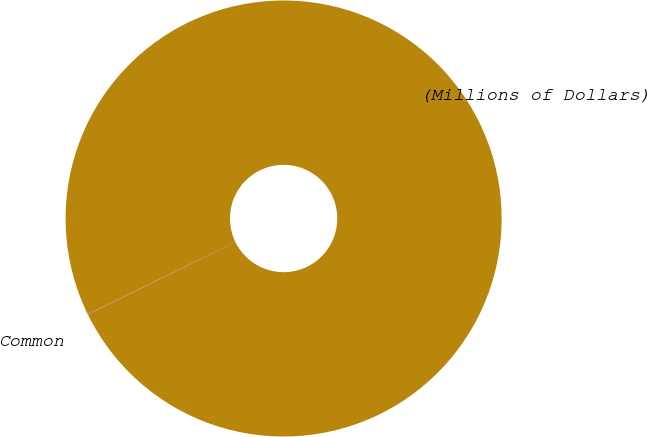Convert chart. <chart><loc_0><loc_0><loc_500><loc_500><pie_chart><fcel>(Millions of Dollars)<fcel>Common<nl><fcel>99.95%<fcel>0.05%<nl></chart> 